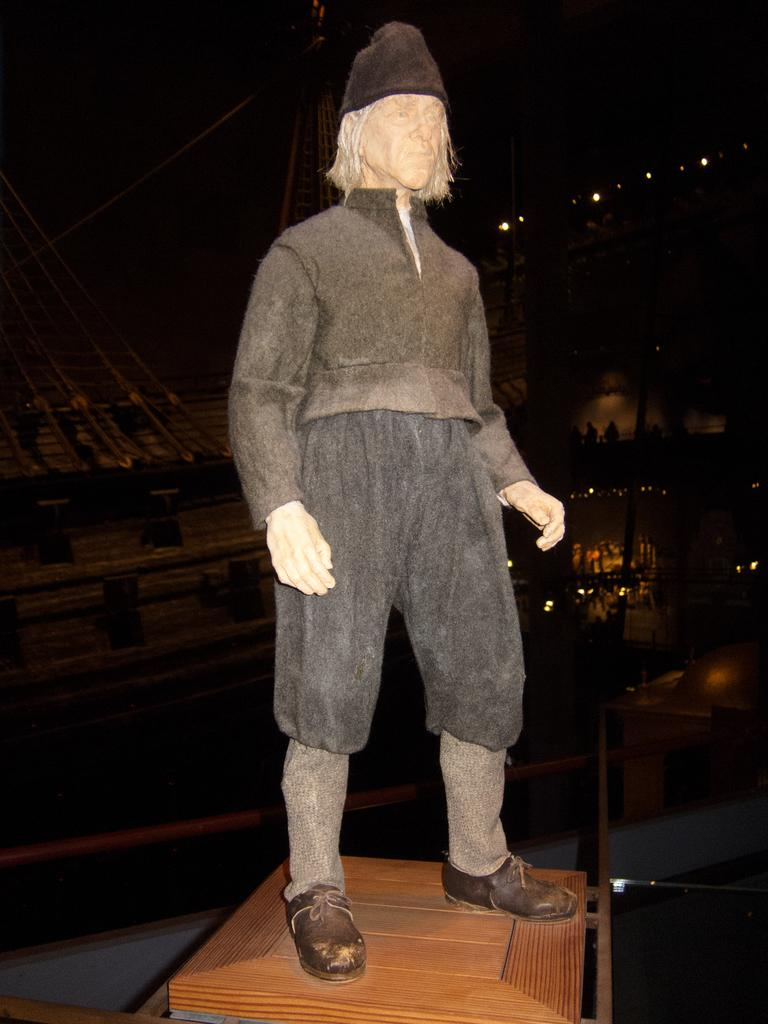What is the main subject of the image? The main subject of the image is a statue of a person. What can be observed about the statue's attire? The statue has clothes, a hat, and shoes. How is the statue positioned in the image? The statue is placed on a wooden block. Can you describe the background of the image? The background is not clear enough to provide a detailed description. How many clocks are visible in the image? There are no clocks present in the image; it features a statue of a person. What type of lake can be seen in the background of the image? There is no lake visible in the image, as the background is not clear enough to identify any specific features. 